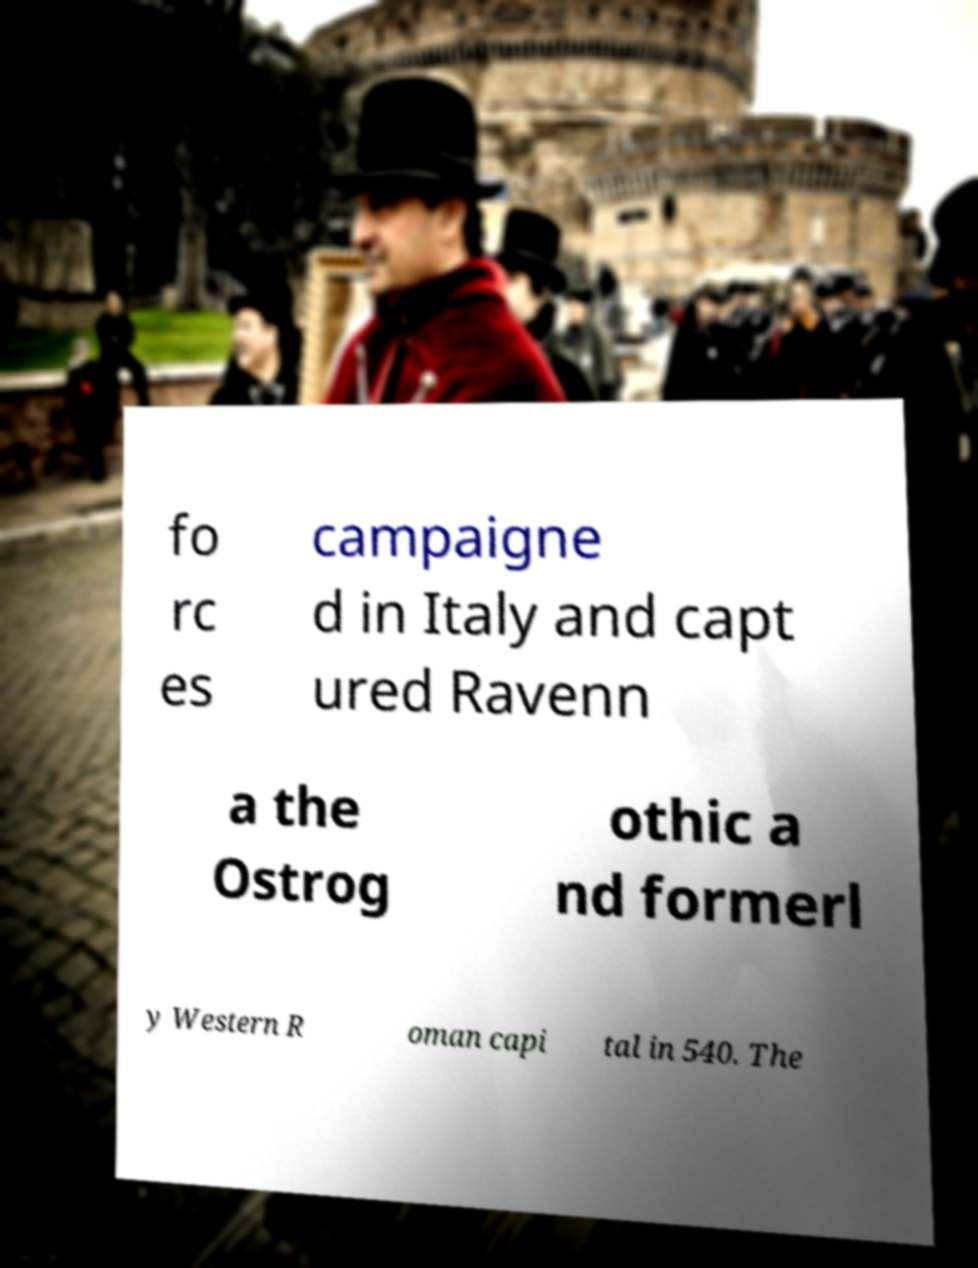Can you accurately transcribe the text from the provided image for me? fo rc es campaigne d in Italy and capt ured Ravenn a the Ostrog othic a nd formerl y Western R oman capi tal in 540. The 